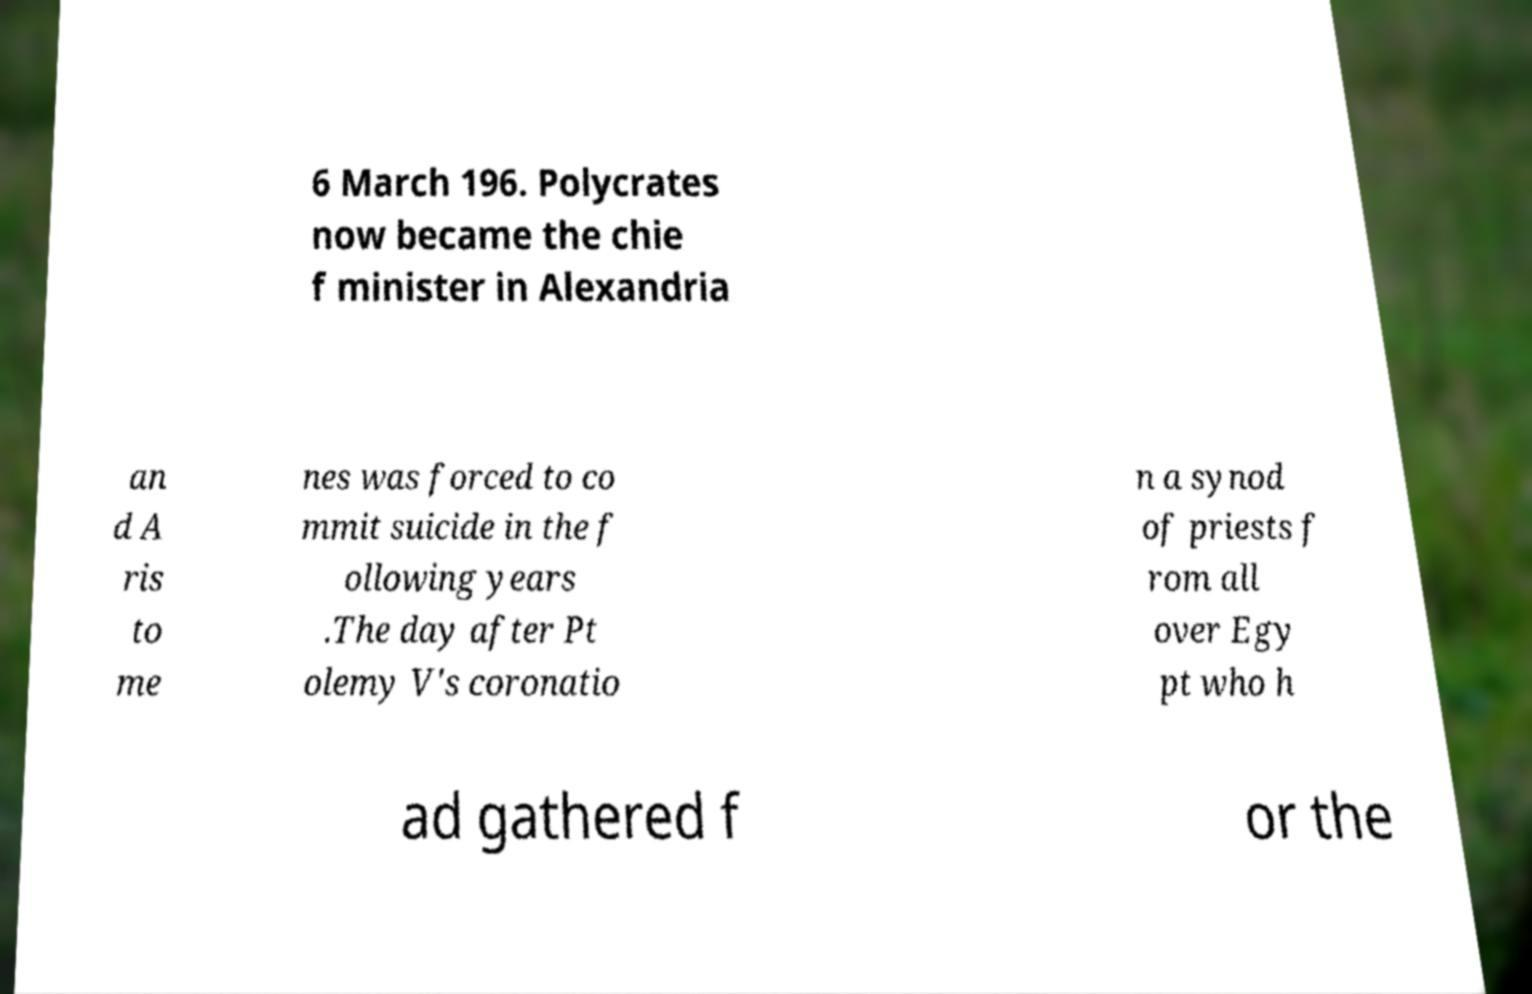Could you extract and type out the text from this image? 6 March 196. Polycrates now became the chie f minister in Alexandria an d A ris to me nes was forced to co mmit suicide in the f ollowing years .The day after Pt olemy V's coronatio n a synod of priests f rom all over Egy pt who h ad gathered f or the 